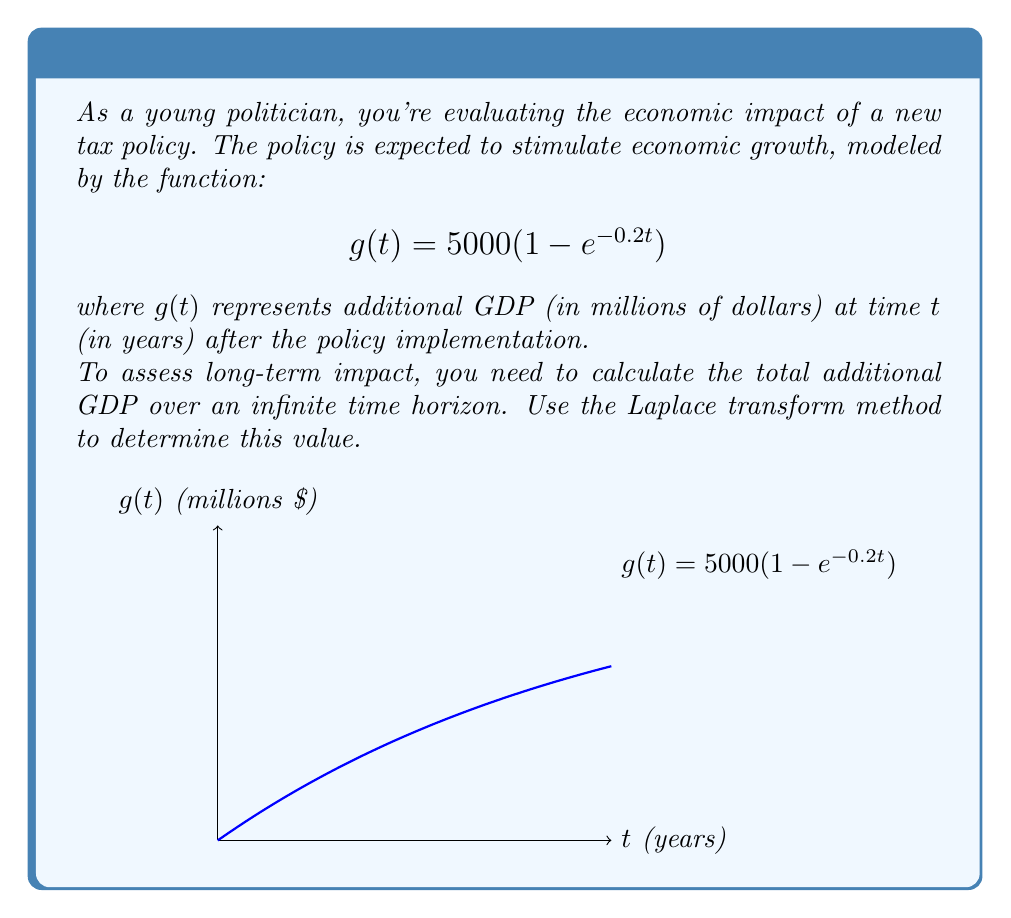Show me your answer to this math problem. Let's approach this step-by-step using the Laplace transform method:

1) The Laplace transform of $g(t)$ is given by:
   $$G(s) = \mathcal{L}\{g(t)\} = \int_0^\infty g(t)e^{-st}dt$$

2) Substituting our function:
   $$G(s) = \int_0^\infty 5000(1 - e^{-0.2t})e^{-st}dt$$

3) This can be split into two integrals:
   $$G(s) = 5000\int_0^\infty e^{-st}dt - 5000\int_0^\infty e^{-(s+0.2)t}dt$$

4) Evaluating these standard integrals:
   $$G(s) = 5000\left[\frac{-1}{s}e^{-st}\right]_0^\infty - 5000\left[\frac{-1}{s+0.2}e^{-(s+0.2)t}\right]_0^\infty$$

5) Simplifying:
   $$G(s) = \frac{5000}{s} - \frac{5000}{s+0.2}$$

6) To find the total GDP over an infinite time horizon, we need to evaluate $\lim_{s \to 0} sG(s)$:
   $$\lim_{s \to 0} sG(s) = \lim_{s \to 0} \left(5000 - \frac{5000s}{s+0.2}\right)$$

7) Evaluating this limit:
   $$\lim_{s \to 0} sG(s) = 5000 - \frac{5000 \cdot 0}{0+0.2} = 5000$$

Therefore, the total additional GDP over an infinite time horizon is $5000 million, or $5 billion.
Answer: $5 billion 